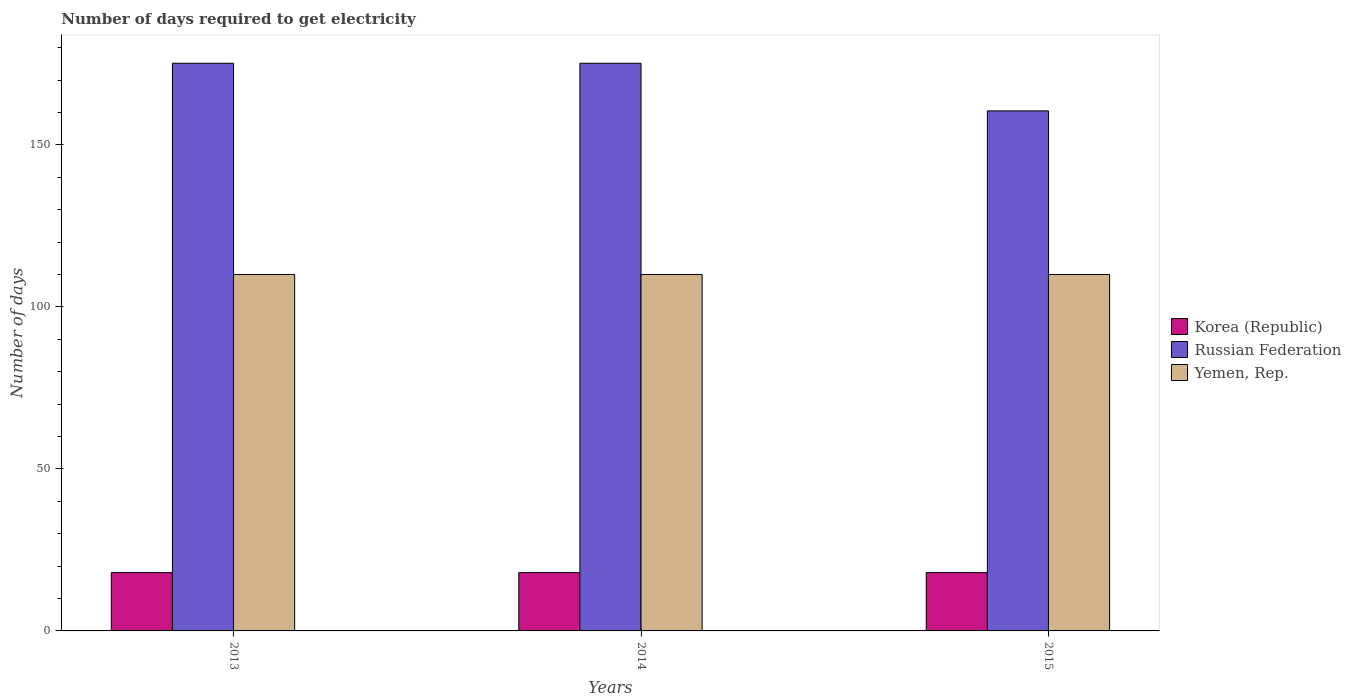How many different coloured bars are there?
Your response must be concise. 3. How many groups of bars are there?
Ensure brevity in your answer.  3. What is the number of days required to get electricity in in Korea (Republic) in 2015?
Ensure brevity in your answer.  18. Across all years, what is the maximum number of days required to get electricity in in Russian Federation?
Keep it short and to the point. 175.2. Across all years, what is the minimum number of days required to get electricity in in Korea (Republic)?
Your answer should be very brief. 18. In which year was the number of days required to get electricity in in Yemen, Rep. maximum?
Offer a very short reply. 2013. What is the total number of days required to get electricity in in Russian Federation in the graph?
Make the answer very short. 510.9. What is the difference between the number of days required to get electricity in in Korea (Republic) in 2014 and the number of days required to get electricity in in Russian Federation in 2013?
Your answer should be very brief. -157.2. What is the average number of days required to get electricity in in Russian Federation per year?
Provide a short and direct response. 170.3. In the year 2014, what is the difference between the number of days required to get electricity in in Russian Federation and number of days required to get electricity in in Yemen, Rep.?
Provide a short and direct response. 65.2. In how many years, is the number of days required to get electricity in in Yemen, Rep. greater than 50 days?
Your answer should be compact. 3. Is the number of days required to get electricity in in Russian Federation in 2013 less than that in 2014?
Your answer should be compact. No. Is the difference between the number of days required to get electricity in in Russian Federation in 2013 and 2015 greater than the difference between the number of days required to get electricity in in Yemen, Rep. in 2013 and 2015?
Offer a very short reply. Yes. What is the difference between the highest and the lowest number of days required to get electricity in in Russian Federation?
Give a very brief answer. 14.7. Is the sum of the number of days required to get electricity in in Yemen, Rep. in 2013 and 2015 greater than the maximum number of days required to get electricity in in Russian Federation across all years?
Offer a very short reply. Yes. What does the 3rd bar from the left in 2015 represents?
Provide a short and direct response. Yemen, Rep. How many bars are there?
Ensure brevity in your answer.  9. How many years are there in the graph?
Provide a short and direct response. 3. Does the graph contain any zero values?
Offer a very short reply. No. Where does the legend appear in the graph?
Provide a short and direct response. Center right. How many legend labels are there?
Keep it short and to the point. 3. How are the legend labels stacked?
Provide a succinct answer. Vertical. What is the title of the graph?
Ensure brevity in your answer.  Number of days required to get electricity. What is the label or title of the Y-axis?
Provide a short and direct response. Number of days. What is the Number of days in Russian Federation in 2013?
Make the answer very short. 175.2. What is the Number of days of Yemen, Rep. in 2013?
Keep it short and to the point. 110. What is the Number of days in Korea (Republic) in 2014?
Make the answer very short. 18. What is the Number of days in Russian Federation in 2014?
Provide a succinct answer. 175.2. What is the Number of days in Yemen, Rep. in 2014?
Keep it short and to the point. 110. What is the Number of days in Russian Federation in 2015?
Give a very brief answer. 160.5. What is the Number of days in Yemen, Rep. in 2015?
Provide a succinct answer. 110. Across all years, what is the maximum Number of days of Russian Federation?
Offer a terse response. 175.2. Across all years, what is the maximum Number of days in Yemen, Rep.?
Provide a short and direct response. 110. Across all years, what is the minimum Number of days in Korea (Republic)?
Offer a very short reply. 18. Across all years, what is the minimum Number of days in Russian Federation?
Offer a very short reply. 160.5. Across all years, what is the minimum Number of days in Yemen, Rep.?
Your answer should be very brief. 110. What is the total Number of days in Korea (Republic) in the graph?
Your answer should be very brief. 54. What is the total Number of days in Russian Federation in the graph?
Give a very brief answer. 510.9. What is the total Number of days in Yemen, Rep. in the graph?
Your answer should be compact. 330. What is the difference between the Number of days in Korea (Republic) in 2013 and that in 2014?
Offer a very short reply. 0. What is the difference between the Number of days of Russian Federation in 2013 and that in 2014?
Keep it short and to the point. 0. What is the difference between the Number of days of Yemen, Rep. in 2013 and that in 2015?
Your answer should be compact. 0. What is the difference between the Number of days of Russian Federation in 2014 and that in 2015?
Offer a very short reply. 14.7. What is the difference between the Number of days in Yemen, Rep. in 2014 and that in 2015?
Your answer should be very brief. 0. What is the difference between the Number of days in Korea (Republic) in 2013 and the Number of days in Russian Federation in 2014?
Your response must be concise. -157.2. What is the difference between the Number of days in Korea (Republic) in 2013 and the Number of days in Yemen, Rep. in 2014?
Ensure brevity in your answer.  -92. What is the difference between the Number of days in Russian Federation in 2013 and the Number of days in Yemen, Rep. in 2014?
Provide a short and direct response. 65.2. What is the difference between the Number of days of Korea (Republic) in 2013 and the Number of days of Russian Federation in 2015?
Your answer should be very brief. -142.5. What is the difference between the Number of days of Korea (Republic) in 2013 and the Number of days of Yemen, Rep. in 2015?
Your answer should be compact. -92. What is the difference between the Number of days in Russian Federation in 2013 and the Number of days in Yemen, Rep. in 2015?
Offer a terse response. 65.2. What is the difference between the Number of days of Korea (Republic) in 2014 and the Number of days of Russian Federation in 2015?
Provide a short and direct response. -142.5. What is the difference between the Number of days of Korea (Republic) in 2014 and the Number of days of Yemen, Rep. in 2015?
Ensure brevity in your answer.  -92. What is the difference between the Number of days in Russian Federation in 2014 and the Number of days in Yemen, Rep. in 2015?
Keep it short and to the point. 65.2. What is the average Number of days of Korea (Republic) per year?
Your answer should be very brief. 18. What is the average Number of days of Russian Federation per year?
Make the answer very short. 170.3. What is the average Number of days in Yemen, Rep. per year?
Provide a short and direct response. 110. In the year 2013, what is the difference between the Number of days of Korea (Republic) and Number of days of Russian Federation?
Provide a short and direct response. -157.2. In the year 2013, what is the difference between the Number of days of Korea (Republic) and Number of days of Yemen, Rep.?
Your response must be concise. -92. In the year 2013, what is the difference between the Number of days of Russian Federation and Number of days of Yemen, Rep.?
Make the answer very short. 65.2. In the year 2014, what is the difference between the Number of days of Korea (Republic) and Number of days of Russian Federation?
Offer a terse response. -157.2. In the year 2014, what is the difference between the Number of days in Korea (Republic) and Number of days in Yemen, Rep.?
Offer a very short reply. -92. In the year 2014, what is the difference between the Number of days in Russian Federation and Number of days in Yemen, Rep.?
Provide a succinct answer. 65.2. In the year 2015, what is the difference between the Number of days in Korea (Republic) and Number of days in Russian Federation?
Provide a succinct answer. -142.5. In the year 2015, what is the difference between the Number of days of Korea (Republic) and Number of days of Yemen, Rep.?
Offer a terse response. -92. In the year 2015, what is the difference between the Number of days of Russian Federation and Number of days of Yemen, Rep.?
Offer a terse response. 50.5. What is the ratio of the Number of days of Korea (Republic) in 2013 to that in 2014?
Your answer should be compact. 1. What is the ratio of the Number of days in Korea (Republic) in 2013 to that in 2015?
Your response must be concise. 1. What is the ratio of the Number of days in Russian Federation in 2013 to that in 2015?
Your answer should be compact. 1.09. What is the ratio of the Number of days in Russian Federation in 2014 to that in 2015?
Provide a succinct answer. 1.09. What is the ratio of the Number of days in Yemen, Rep. in 2014 to that in 2015?
Keep it short and to the point. 1. What is the difference between the highest and the second highest Number of days in Korea (Republic)?
Your answer should be very brief. 0. What is the difference between the highest and the second highest Number of days in Yemen, Rep.?
Your answer should be very brief. 0. 